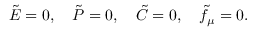<formula> <loc_0><loc_0><loc_500><loc_500>\tilde { E } = 0 , \tilde { P } = 0 , \tilde { C } = 0 , \tilde { f } _ { \mu } = 0 .</formula> 